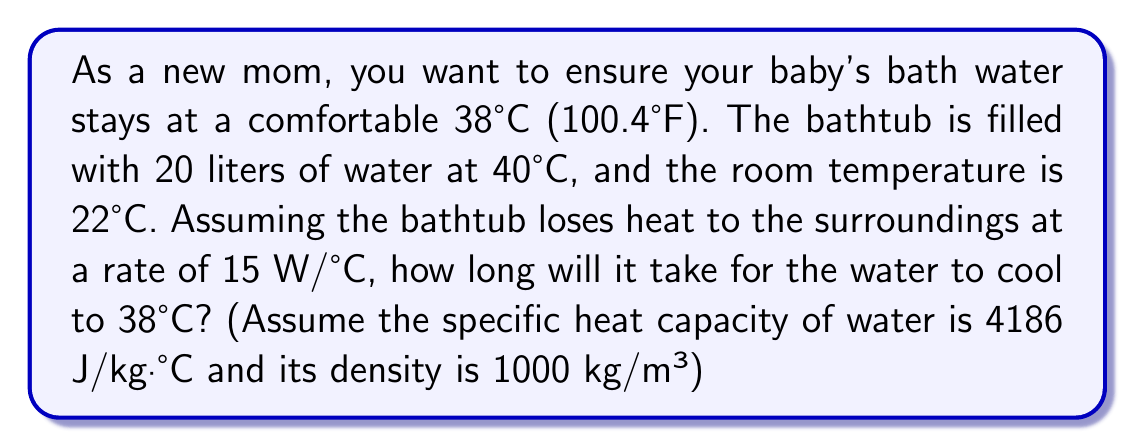Can you solve this math problem? Let's approach this step-by-step:

1) First, we need to calculate the mass of water:
   Volume = 20 liters = 0.02 m³
   Density = 1000 kg/m³
   Mass = Density × Volume = 1000 × 0.02 = 20 kg

2) Now, we can use the heat transfer equation:
   $$ Q = mc\Delta T $$
   Where:
   $Q$ = heat energy transferred (J)
   $m$ = mass of water (20 kg)
   $c$ = specific heat capacity of water (4186 J/kg·°C)
   $\Delta T$ = change in temperature (40°C - 38°C = 2°C)

3) Let's calculate $Q$:
   $$ Q = 20 \times 4186 \times 2 = 167,440 \text{ J} $$

4) The rate of heat loss is given by:
   $$ \text{Rate} = k\Delta T $$
   Where:
   $k$ = heat transfer coefficient (15 W/°C)
   $\Delta T$ = temperature difference between water and room (38°C - 22°C = 16°C)

5) Calculate the rate:
   $$ \text{Rate} = 15 \times 16 = 240 \text{ W} = 240 \text{ J/s} $$

6) Time can be calculated by dividing total heat energy by rate:
   $$ t = \frac{Q}{\text{Rate}} = \frac{167,440}{240} = 697.67 \text{ seconds} $$

7) Convert to minutes:
   $$ 697.67 \div 60 = 11.63 \text{ minutes} $$
Answer: 11.63 minutes 